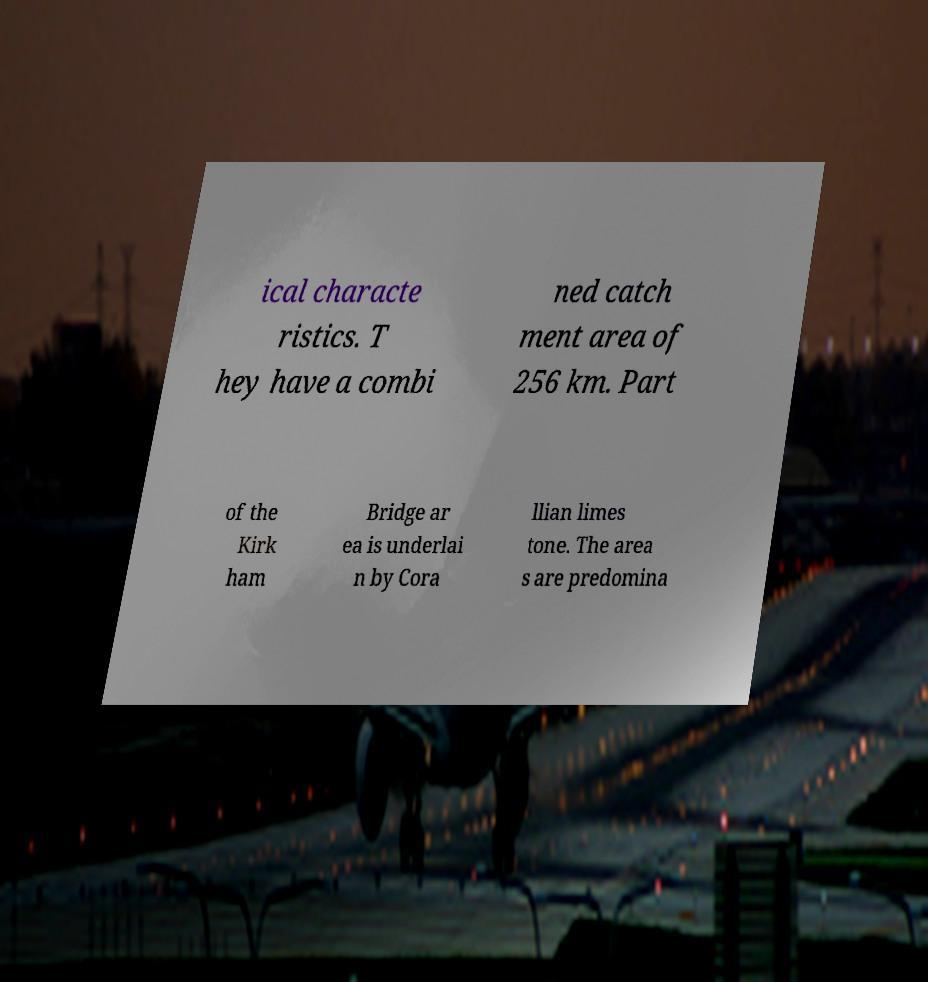I need the written content from this picture converted into text. Can you do that? ical characte ristics. T hey have a combi ned catch ment area of 256 km. Part of the Kirk ham Bridge ar ea is underlai n by Cora llian limes tone. The area s are predomina 